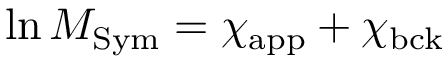Convert formula to latex. <formula><loc_0><loc_0><loc_500><loc_500>\ln M _ { S y m } = \chi _ { a p p } + \chi _ { b c k }</formula> 